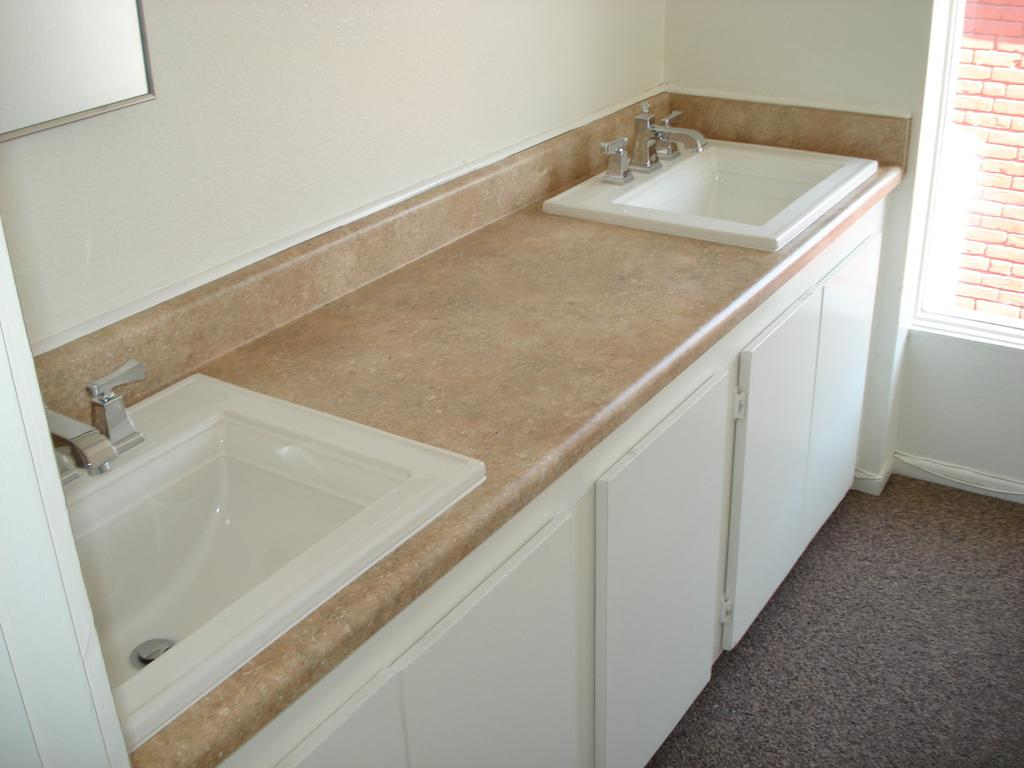What type of furniture is present in the image? There are cupboards in the image. What can be found in the room for washing purposes? There are washbasins in the image. Is there any source of natural light in the room? Yes, there is a window in the image. What is attached to the wall in the image? There is a chart attached to the wall in the image. What thrilling activity is happening in the image? There is no thrilling activity happening in the image; it depicts cupboards, washbasins, a window, and a chart on the wall. How many drops of water can be seen falling from the window in the image? There is no mention of water or drops in the image; it only shows a window. 